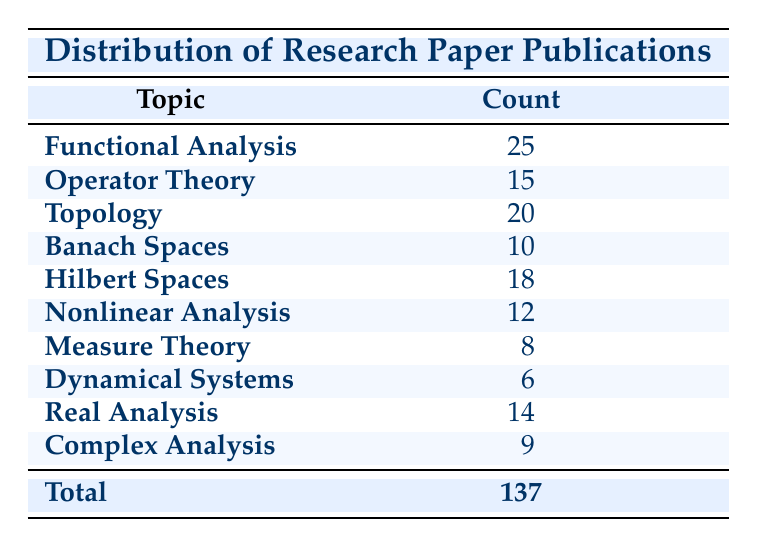What is the topic with the highest number of publications? According to the table, "Functional Analysis" has the highest count of 25 publications.
Answer: Functional Analysis How many publications are there in "Hilbert Spaces"? The table indicates there are 18 publications in "Hilbert Spaces."
Answer: 18 What is the total number of publications across all topics listed? The total number of publications is given directly in the table as 137.
Answer: 137 Which topic has the lowest number of publications? The table shows that "Dynamical Systems" has the lowest count with only 6 publications.
Answer: Dynamical Systems What is the average number of publications for the topics listed? First, add all the publication counts: 25 + 15 + 20 + 10 + 18 + 12 + 8 + 6 + 14 + 9 = 137. There are 10 topics, so the average is 137/10 = 13.7.
Answer: 13.7 Is there a topic with more than 20 publications? Yes, "Functional Analysis" and "Topology" have more than 20 publications, with counts of 25 and 20, respectively.
Answer: Yes How many more publications does "Functional Analysis" have compared to "Nonlinear Analysis"? "Functional Analysis" has 25 publications, while "Nonlinear Analysis" has 12. The difference is 25 - 12 = 13.
Answer: 13 What percentage of the total publications does "Measure Theory" represent? "Measure Theory" has 8 publications out of a total of 137. The percentage is (8/137) * 100 ≈ 5.84%.
Answer: 5.84% Are there any topics with counts less than 10? Yes, "Banach Spaces" (10), "Measure Theory" (8), and "Dynamical Systems" (6) are less than 10. Therefore, there are topics with counts less than 10.
Answer: Yes What is the sum of publications for "Operator Theory," "Real Analysis," and "Complex Analysis"? The counts for these topics are "Operator Theory" 15, "Real Analysis" 14, and "Complex Analysis" 9. The sum is 15 + 14 + 9 = 38.
Answer: 38 